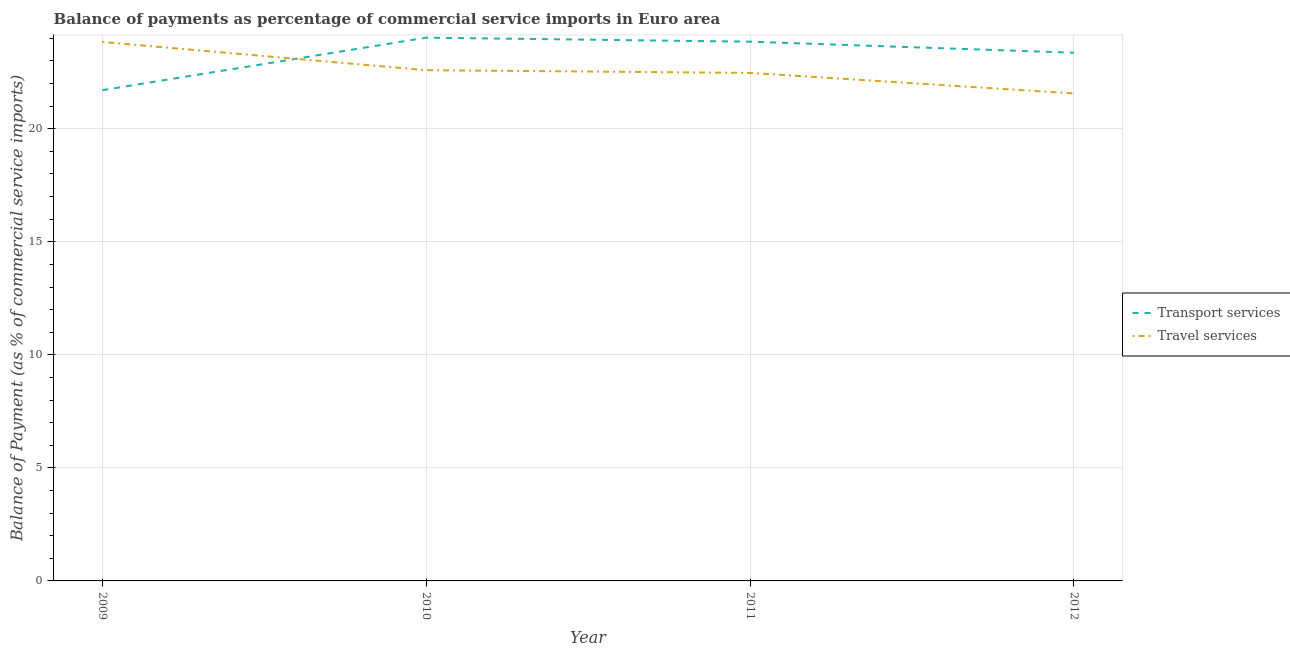What is the balance of payments of transport services in 2011?
Offer a terse response. 23.85. Across all years, what is the maximum balance of payments of transport services?
Your answer should be very brief. 24.03. Across all years, what is the minimum balance of payments of travel services?
Your response must be concise. 21.56. In which year was the balance of payments of transport services maximum?
Ensure brevity in your answer.  2010. What is the total balance of payments of travel services in the graph?
Your response must be concise. 90.46. What is the difference between the balance of payments of transport services in 2010 and that in 2012?
Provide a succinct answer. 0.67. What is the difference between the balance of payments of travel services in 2011 and the balance of payments of transport services in 2009?
Make the answer very short. 0.77. What is the average balance of payments of transport services per year?
Ensure brevity in your answer.  23.24. In the year 2009, what is the difference between the balance of payments of transport services and balance of payments of travel services?
Ensure brevity in your answer.  -2.13. In how many years, is the balance of payments of transport services greater than 5 %?
Ensure brevity in your answer.  4. What is the ratio of the balance of payments of transport services in 2009 to that in 2011?
Offer a very short reply. 0.91. What is the difference between the highest and the second highest balance of payments of travel services?
Provide a succinct answer. 1.25. What is the difference between the highest and the lowest balance of payments of travel services?
Provide a short and direct response. 2.28. Does the balance of payments of travel services monotonically increase over the years?
Provide a succinct answer. No. How many years are there in the graph?
Your response must be concise. 4. What is the difference between two consecutive major ticks on the Y-axis?
Provide a succinct answer. 5. Does the graph contain any zero values?
Make the answer very short. No. How many legend labels are there?
Offer a very short reply. 2. What is the title of the graph?
Offer a very short reply. Balance of payments as percentage of commercial service imports in Euro area. Does "Formally registered" appear as one of the legend labels in the graph?
Your answer should be compact. No. What is the label or title of the Y-axis?
Make the answer very short. Balance of Payment (as % of commercial service imports). What is the Balance of Payment (as % of commercial service imports) in Transport services in 2009?
Provide a short and direct response. 21.71. What is the Balance of Payment (as % of commercial service imports) in Travel services in 2009?
Offer a terse response. 23.84. What is the Balance of Payment (as % of commercial service imports) of Transport services in 2010?
Ensure brevity in your answer.  24.03. What is the Balance of Payment (as % of commercial service imports) in Travel services in 2010?
Your response must be concise. 22.59. What is the Balance of Payment (as % of commercial service imports) in Transport services in 2011?
Your answer should be compact. 23.85. What is the Balance of Payment (as % of commercial service imports) in Travel services in 2011?
Provide a succinct answer. 22.47. What is the Balance of Payment (as % of commercial service imports) in Transport services in 2012?
Ensure brevity in your answer.  23.36. What is the Balance of Payment (as % of commercial service imports) in Travel services in 2012?
Make the answer very short. 21.56. Across all years, what is the maximum Balance of Payment (as % of commercial service imports) in Transport services?
Offer a very short reply. 24.03. Across all years, what is the maximum Balance of Payment (as % of commercial service imports) in Travel services?
Your response must be concise. 23.84. Across all years, what is the minimum Balance of Payment (as % of commercial service imports) in Transport services?
Offer a very short reply. 21.71. Across all years, what is the minimum Balance of Payment (as % of commercial service imports) in Travel services?
Give a very brief answer. 21.56. What is the total Balance of Payment (as % of commercial service imports) of Transport services in the graph?
Offer a very short reply. 92.95. What is the total Balance of Payment (as % of commercial service imports) in Travel services in the graph?
Provide a short and direct response. 90.46. What is the difference between the Balance of Payment (as % of commercial service imports) of Transport services in 2009 and that in 2010?
Ensure brevity in your answer.  -2.32. What is the difference between the Balance of Payment (as % of commercial service imports) of Travel services in 2009 and that in 2010?
Ensure brevity in your answer.  1.25. What is the difference between the Balance of Payment (as % of commercial service imports) of Transport services in 2009 and that in 2011?
Keep it short and to the point. -2.15. What is the difference between the Balance of Payment (as % of commercial service imports) in Travel services in 2009 and that in 2011?
Ensure brevity in your answer.  1.37. What is the difference between the Balance of Payment (as % of commercial service imports) in Transport services in 2009 and that in 2012?
Ensure brevity in your answer.  -1.66. What is the difference between the Balance of Payment (as % of commercial service imports) of Travel services in 2009 and that in 2012?
Provide a succinct answer. 2.28. What is the difference between the Balance of Payment (as % of commercial service imports) of Transport services in 2010 and that in 2011?
Offer a terse response. 0.18. What is the difference between the Balance of Payment (as % of commercial service imports) in Travel services in 2010 and that in 2011?
Give a very brief answer. 0.12. What is the difference between the Balance of Payment (as % of commercial service imports) in Transport services in 2010 and that in 2012?
Your answer should be compact. 0.67. What is the difference between the Balance of Payment (as % of commercial service imports) of Travel services in 2010 and that in 2012?
Provide a short and direct response. 1.03. What is the difference between the Balance of Payment (as % of commercial service imports) of Transport services in 2011 and that in 2012?
Provide a short and direct response. 0.49. What is the difference between the Balance of Payment (as % of commercial service imports) of Travel services in 2011 and that in 2012?
Your response must be concise. 0.91. What is the difference between the Balance of Payment (as % of commercial service imports) in Transport services in 2009 and the Balance of Payment (as % of commercial service imports) in Travel services in 2010?
Your response must be concise. -0.89. What is the difference between the Balance of Payment (as % of commercial service imports) of Transport services in 2009 and the Balance of Payment (as % of commercial service imports) of Travel services in 2011?
Offer a very short reply. -0.77. What is the difference between the Balance of Payment (as % of commercial service imports) of Transport services in 2009 and the Balance of Payment (as % of commercial service imports) of Travel services in 2012?
Your answer should be compact. 0.14. What is the difference between the Balance of Payment (as % of commercial service imports) of Transport services in 2010 and the Balance of Payment (as % of commercial service imports) of Travel services in 2011?
Ensure brevity in your answer.  1.56. What is the difference between the Balance of Payment (as % of commercial service imports) of Transport services in 2010 and the Balance of Payment (as % of commercial service imports) of Travel services in 2012?
Your response must be concise. 2.47. What is the difference between the Balance of Payment (as % of commercial service imports) in Transport services in 2011 and the Balance of Payment (as % of commercial service imports) in Travel services in 2012?
Provide a succinct answer. 2.29. What is the average Balance of Payment (as % of commercial service imports) in Transport services per year?
Provide a succinct answer. 23.24. What is the average Balance of Payment (as % of commercial service imports) in Travel services per year?
Provide a short and direct response. 22.62. In the year 2009, what is the difference between the Balance of Payment (as % of commercial service imports) in Transport services and Balance of Payment (as % of commercial service imports) in Travel services?
Offer a very short reply. -2.13. In the year 2010, what is the difference between the Balance of Payment (as % of commercial service imports) of Transport services and Balance of Payment (as % of commercial service imports) of Travel services?
Offer a very short reply. 1.44. In the year 2011, what is the difference between the Balance of Payment (as % of commercial service imports) in Transport services and Balance of Payment (as % of commercial service imports) in Travel services?
Offer a very short reply. 1.38. In the year 2012, what is the difference between the Balance of Payment (as % of commercial service imports) of Transport services and Balance of Payment (as % of commercial service imports) of Travel services?
Your answer should be compact. 1.8. What is the ratio of the Balance of Payment (as % of commercial service imports) in Transport services in 2009 to that in 2010?
Provide a short and direct response. 0.9. What is the ratio of the Balance of Payment (as % of commercial service imports) in Travel services in 2009 to that in 2010?
Offer a very short reply. 1.06. What is the ratio of the Balance of Payment (as % of commercial service imports) in Transport services in 2009 to that in 2011?
Make the answer very short. 0.91. What is the ratio of the Balance of Payment (as % of commercial service imports) of Travel services in 2009 to that in 2011?
Keep it short and to the point. 1.06. What is the ratio of the Balance of Payment (as % of commercial service imports) in Transport services in 2009 to that in 2012?
Give a very brief answer. 0.93. What is the ratio of the Balance of Payment (as % of commercial service imports) in Travel services in 2009 to that in 2012?
Give a very brief answer. 1.11. What is the ratio of the Balance of Payment (as % of commercial service imports) in Transport services in 2010 to that in 2011?
Keep it short and to the point. 1.01. What is the ratio of the Balance of Payment (as % of commercial service imports) in Transport services in 2010 to that in 2012?
Make the answer very short. 1.03. What is the ratio of the Balance of Payment (as % of commercial service imports) in Travel services in 2010 to that in 2012?
Keep it short and to the point. 1.05. What is the ratio of the Balance of Payment (as % of commercial service imports) of Transport services in 2011 to that in 2012?
Provide a short and direct response. 1.02. What is the ratio of the Balance of Payment (as % of commercial service imports) of Travel services in 2011 to that in 2012?
Keep it short and to the point. 1.04. What is the difference between the highest and the second highest Balance of Payment (as % of commercial service imports) of Transport services?
Make the answer very short. 0.18. What is the difference between the highest and the second highest Balance of Payment (as % of commercial service imports) in Travel services?
Keep it short and to the point. 1.25. What is the difference between the highest and the lowest Balance of Payment (as % of commercial service imports) of Transport services?
Your answer should be compact. 2.32. What is the difference between the highest and the lowest Balance of Payment (as % of commercial service imports) of Travel services?
Make the answer very short. 2.28. 